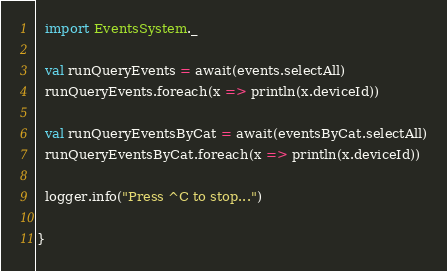<code> <loc_0><loc_0><loc_500><loc_500><_Scala_>
  import EventsSystem._

  val runQueryEvents = await(events.selectAll)
  runQueryEvents.foreach(x => println(x.deviceId))

  val runQueryEventsByCat = await(eventsByCat.selectAll)
  runQueryEventsByCat.foreach(x => println(x.deviceId))

  logger.info("Press ^C to stop...")

}
</code> 